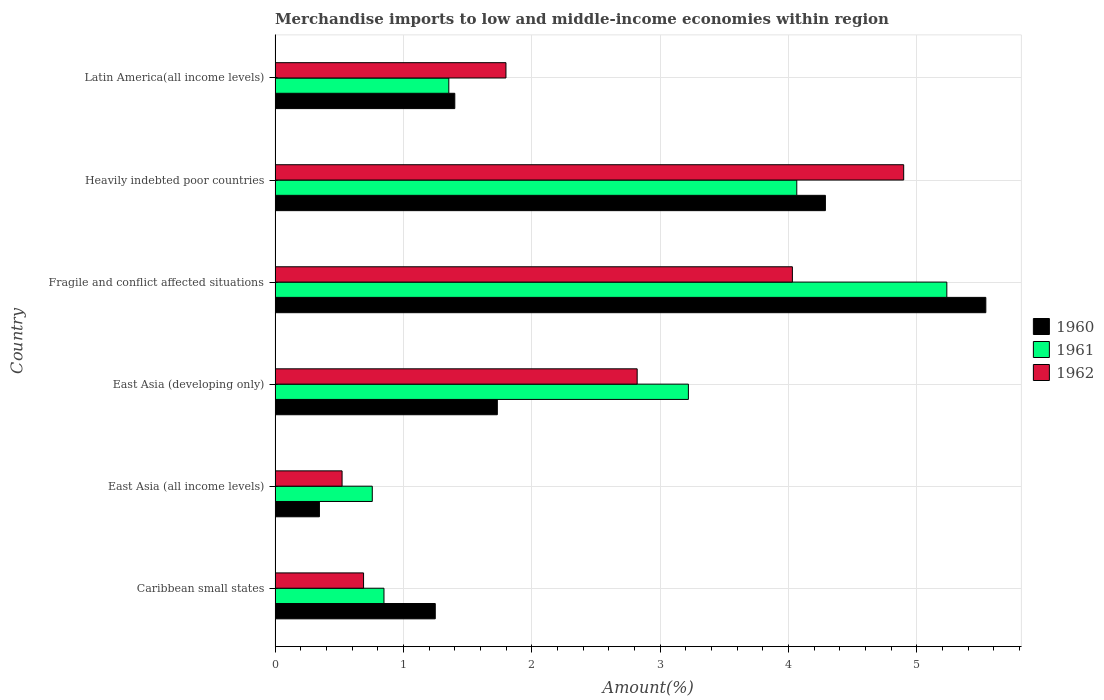Are the number of bars per tick equal to the number of legend labels?
Your response must be concise. Yes. How many bars are there on the 4th tick from the bottom?
Offer a very short reply. 3. What is the label of the 6th group of bars from the top?
Your answer should be compact. Caribbean small states. What is the percentage of amount earned from merchandise imports in 1962 in Latin America(all income levels)?
Give a very brief answer. 1.8. Across all countries, what is the maximum percentage of amount earned from merchandise imports in 1960?
Keep it short and to the point. 5.54. Across all countries, what is the minimum percentage of amount earned from merchandise imports in 1962?
Offer a very short reply. 0.52. In which country was the percentage of amount earned from merchandise imports in 1961 maximum?
Make the answer very short. Fragile and conflict affected situations. In which country was the percentage of amount earned from merchandise imports in 1961 minimum?
Make the answer very short. East Asia (all income levels). What is the total percentage of amount earned from merchandise imports in 1962 in the graph?
Your answer should be very brief. 14.76. What is the difference between the percentage of amount earned from merchandise imports in 1962 in Caribbean small states and that in East Asia (all income levels)?
Your answer should be very brief. 0.17. What is the difference between the percentage of amount earned from merchandise imports in 1961 in Caribbean small states and the percentage of amount earned from merchandise imports in 1962 in Fragile and conflict affected situations?
Your response must be concise. -3.18. What is the average percentage of amount earned from merchandise imports in 1960 per country?
Provide a succinct answer. 2.43. What is the difference between the percentage of amount earned from merchandise imports in 1961 and percentage of amount earned from merchandise imports in 1962 in Caribbean small states?
Make the answer very short. 0.16. In how many countries, is the percentage of amount earned from merchandise imports in 1961 greater than 2.4 %?
Provide a short and direct response. 3. What is the ratio of the percentage of amount earned from merchandise imports in 1961 in Heavily indebted poor countries to that in Latin America(all income levels)?
Your response must be concise. 3. Is the percentage of amount earned from merchandise imports in 1961 in East Asia (developing only) less than that in Fragile and conflict affected situations?
Provide a short and direct response. Yes. Is the difference between the percentage of amount earned from merchandise imports in 1961 in East Asia (all income levels) and Latin America(all income levels) greater than the difference between the percentage of amount earned from merchandise imports in 1962 in East Asia (all income levels) and Latin America(all income levels)?
Make the answer very short. Yes. What is the difference between the highest and the second highest percentage of amount earned from merchandise imports in 1961?
Keep it short and to the point. 1.17. What is the difference between the highest and the lowest percentage of amount earned from merchandise imports in 1961?
Give a very brief answer. 4.48. In how many countries, is the percentage of amount earned from merchandise imports in 1961 greater than the average percentage of amount earned from merchandise imports in 1961 taken over all countries?
Your answer should be very brief. 3. Is the sum of the percentage of amount earned from merchandise imports in 1960 in East Asia (all income levels) and Latin America(all income levels) greater than the maximum percentage of amount earned from merchandise imports in 1962 across all countries?
Ensure brevity in your answer.  No. What does the 3rd bar from the top in Fragile and conflict affected situations represents?
Ensure brevity in your answer.  1960. Is it the case that in every country, the sum of the percentage of amount earned from merchandise imports in 1962 and percentage of amount earned from merchandise imports in 1961 is greater than the percentage of amount earned from merchandise imports in 1960?
Give a very brief answer. Yes. How many bars are there?
Offer a terse response. 18. How many legend labels are there?
Provide a succinct answer. 3. What is the title of the graph?
Give a very brief answer. Merchandise imports to low and middle-income economies within region. What is the label or title of the X-axis?
Ensure brevity in your answer.  Amount(%). What is the label or title of the Y-axis?
Offer a terse response. Country. What is the Amount(%) in 1960 in Caribbean small states?
Your response must be concise. 1.25. What is the Amount(%) of 1961 in Caribbean small states?
Offer a very short reply. 0.85. What is the Amount(%) in 1962 in Caribbean small states?
Your response must be concise. 0.69. What is the Amount(%) of 1960 in East Asia (all income levels)?
Provide a short and direct response. 0.35. What is the Amount(%) of 1961 in East Asia (all income levels)?
Offer a very short reply. 0.76. What is the Amount(%) in 1962 in East Asia (all income levels)?
Keep it short and to the point. 0.52. What is the Amount(%) in 1960 in East Asia (developing only)?
Provide a short and direct response. 1.73. What is the Amount(%) in 1961 in East Asia (developing only)?
Give a very brief answer. 3.22. What is the Amount(%) in 1962 in East Asia (developing only)?
Offer a very short reply. 2.82. What is the Amount(%) in 1960 in Fragile and conflict affected situations?
Offer a very short reply. 5.54. What is the Amount(%) of 1961 in Fragile and conflict affected situations?
Your answer should be very brief. 5.23. What is the Amount(%) in 1962 in Fragile and conflict affected situations?
Provide a short and direct response. 4.03. What is the Amount(%) in 1960 in Heavily indebted poor countries?
Your answer should be very brief. 4.29. What is the Amount(%) in 1961 in Heavily indebted poor countries?
Your response must be concise. 4.06. What is the Amount(%) of 1962 in Heavily indebted poor countries?
Offer a terse response. 4.9. What is the Amount(%) of 1960 in Latin America(all income levels)?
Your response must be concise. 1.4. What is the Amount(%) of 1961 in Latin America(all income levels)?
Ensure brevity in your answer.  1.35. What is the Amount(%) of 1962 in Latin America(all income levels)?
Your answer should be very brief. 1.8. Across all countries, what is the maximum Amount(%) of 1960?
Provide a succinct answer. 5.54. Across all countries, what is the maximum Amount(%) of 1961?
Keep it short and to the point. 5.23. Across all countries, what is the maximum Amount(%) of 1962?
Make the answer very short. 4.9. Across all countries, what is the minimum Amount(%) in 1960?
Your response must be concise. 0.35. Across all countries, what is the minimum Amount(%) of 1961?
Offer a very short reply. 0.76. Across all countries, what is the minimum Amount(%) of 1962?
Ensure brevity in your answer.  0.52. What is the total Amount(%) of 1960 in the graph?
Provide a short and direct response. 14.55. What is the total Amount(%) in 1961 in the graph?
Offer a terse response. 15.48. What is the total Amount(%) of 1962 in the graph?
Provide a short and direct response. 14.76. What is the difference between the Amount(%) in 1960 in Caribbean small states and that in East Asia (all income levels)?
Keep it short and to the point. 0.9. What is the difference between the Amount(%) of 1961 in Caribbean small states and that in East Asia (all income levels)?
Give a very brief answer. 0.09. What is the difference between the Amount(%) of 1962 in Caribbean small states and that in East Asia (all income levels)?
Ensure brevity in your answer.  0.17. What is the difference between the Amount(%) in 1960 in Caribbean small states and that in East Asia (developing only)?
Provide a short and direct response. -0.48. What is the difference between the Amount(%) of 1961 in Caribbean small states and that in East Asia (developing only)?
Make the answer very short. -2.37. What is the difference between the Amount(%) of 1962 in Caribbean small states and that in East Asia (developing only)?
Provide a succinct answer. -2.13. What is the difference between the Amount(%) of 1960 in Caribbean small states and that in Fragile and conflict affected situations?
Your answer should be very brief. -4.29. What is the difference between the Amount(%) of 1961 in Caribbean small states and that in Fragile and conflict affected situations?
Your answer should be compact. -4.39. What is the difference between the Amount(%) of 1962 in Caribbean small states and that in Fragile and conflict affected situations?
Offer a terse response. -3.34. What is the difference between the Amount(%) of 1960 in Caribbean small states and that in Heavily indebted poor countries?
Your answer should be very brief. -3.04. What is the difference between the Amount(%) of 1961 in Caribbean small states and that in Heavily indebted poor countries?
Offer a very short reply. -3.22. What is the difference between the Amount(%) in 1962 in Caribbean small states and that in Heavily indebted poor countries?
Provide a short and direct response. -4.21. What is the difference between the Amount(%) of 1960 in Caribbean small states and that in Latin America(all income levels)?
Make the answer very short. -0.15. What is the difference between the Amount(%) in 1961 in Caribbean small states and that in Latin America(all income levels)?
Provide a short and direct response. -0.51. What is the difference between the Amount(%) of 1962 in Caribbean small states and that in Latin America(all income levels)?
Keep it short and to the point. -1.11. What is the difference between the Amount(%) in 1960 in East Asia (all income levels) and that in East Asia (developing only)?
Offer a very short reply. -1.39. What is the difference between the Amount(%) of 1961 in East Asia (all income levels) and that in East Asia (developing only)?
Make the answer very short. -2.46. What is the difference between the Amount(%) in 1962 in East Asia (all income levels) and that in East Asia (developing only)?
Offer a very short reply. -2.3. What is the difference between the Amount(%) of 1960 in East Asia (all income levels) and that in Fragile and conflict affected situations?
Offer a terse response. -5.19. What is the difference between the Amount(%) of 1961 in East Asia (all income levels) and that in Fragile and conflict affected situations?
Offer a terse response. -4.48. What is the difference between the Amount(%) in 1962 in East Asia (all income levels) and that in Fragile and conflict affected situations?
Your response must be concise. -3.51. What is the difference between the Amount(%) in 1960 in East Asia (all income levels) and that in Heavily indebted poor countries?
Ensure brevity in your answer.  -3.94. What is the difference between the Amount(%) of 1961 in East Asia (all income levels) and that in Heavily indebted poor countries?
Make the answer very short. -3.31. What is the difference between the Amount(%) of 1962 in East Asia (all income levels) and that in Heavily indebted poor countries?
Your response must be concise. -4.38. What is the difference between the Amount(%) of 1960 in East Asia (all income levels) and that in Latin America(all income levels)?
Ensure brevity in your answer.  -1.05. What is the difference between the Amount(%) of 1961 in East Asia (all income levels) and that in Latin America(all income levels)?
Ensure brevity in your answer.  -0.6. What is the difference between the Amount(%) of 1962 in East Asia (all income levels) and that in Latin America(all income levels)?
Provide a succinct answer. -1.28. What is the difference between the Amount(%) of 1960 in East Asia (developing only) and that in Fragile and conflict affected situations?
Your answer should be very brief. -3.81. What is the difference between the Amount(%) in 1961 in East Asia (developing only) and that in Fragile and conflict affected situations?
Give a very brief answer. -2.01. What is the difference between the Amount(%) of 1962 in East Asia (developing only) and that in Fragile and conflict affected situations?
Keep it short and to the point. -1.21. What is the difference between the Amount(%) in 1960 in East Asia (developing only) and that in Heavily indebted poor countries?
Give a very brief answer. -2.56. What is the difference between the Amount(%) in 1961 in East Asia (developing only) and that in Heavily indebted poor countries?
Provide a short and direct response. -0.84. What is the difference between the Amount(%) in 1962 in East Asia (developing only) and that in Heavily indebted poor countries?
Your answer should be compact. -2.08. What is the difference between the Amount(%) of 1960 in East Asia (developing only) and that in Latin America(all income levels)?
Your answer should be very brief. 0.33. What is the difference between the Amount(%) in 1961 in East Asia (developing only) and that in Latin America(all income levels)?
Keep it short and to the point. 1.87. What is the difference between the Amount(%) in 1962 in East Asia (developing only) and that in Latin America(all income levels)?
Make the answer very short. 1.02. What is the difference between the Amount(%) of 1960 in Fragile and conflict affected situations and that in Heavily indebted poor countries?
Your answer should be compact. 1.25. What is the difference between the Amount(%) of 1961 in Fragile and conflict affected situations and that in Heavily indebted poor countries?
Your response must be concise. 1.17. What is the difference between the Amount(%) of 1962 in Fragile and conflict affected situations and that in Heavily indebted poor countries?
Keep it short and to the point. -0.87. What is the difference between the Amount(%) in 1960 in Fragile and conflict affected situations and that in Latin America(all income levels)?
Offer a terse response. 4.14. What is the difference between the Amount(%) in 1961 in Fragile and conflict affected situations and that in Latin America(all income levels)?
Keep it short and to the point. 3.88. What is the difference between the Amount(%) of 1962 in Fragile and conflict affected situations and that in Latin America(all income levels)?
Offer a terse response. 2.23. What is the difference between the Amount(%) in 1960 in Heavily indebted poor countries and that in Latin America(all income levels)?
Give a very brief answer. 2.89. What is the difference between the Amount(%) of 1961 in Heavily indebted poor countries and that in Latin America(all income levels)?
Offer a very short reply. 2.71. What is the difference between the Amount(%) of 1962 in Heavily indebted poor countries and that in Latin America(all income levels)?
Give a very brief answer. 3.1. What is the difference between the Amount(%) in 1960 in Caribbean small states and the Amount(%) in 1961 in East Asia (all income levels)?
Keep it short and to the point. 0.49. What is the difference between the Amount(%) in 1960 in Caribbean small states and the Amount(%) in 1962 in East Asia (all income levels)?
Provide a succinct answer. 0.73. What is the difference between the Amount(%) of 1961 in Caribbean small states and the Amount(%) of 1962 in East Asia (all income levels)?
Provide a succinct answer. 0.33. What is the difference between the Amount(%) in 1960 in Caribbean small states and the Amount(%) in 1961 in East Asia (developing only)?
Offer a very short reply. -1.97. What is the difference between the Amount(%) of 1960 in Caribbean small states and the Amount(%) of 1962 in East Asia (developing only)?
Your answer should be compact. -1.57. What is the difference between the Amount(%) of 1961 in Caribbean small states and the Amount(%) of 1962 in East Asia (developing only)?
Offer a terse response. -1.97. What is the difference between the Amount(%) in 1960 in Caribbean small states and the Amount(%) in 1961 in Fragile and conflict affected situations?
Ensure brevity in your answer.  -3.99. What is the difference between the Amount(%) of 1960 in Caribbean small states and the Amount(%) of 1962 in Fragile and conflict affected situations?
Keep it short and to the point. -2.78. What is the difference between the Amount(%) of 1961 in Caribbean small states and the Amount(%) of 1962 in Fragile and conflict affected situations?
Provide a short and direct response. -3.18. What is the difference between the Amount(%) of 1960 in Caribbean small states and the Amount(%) of 1961 in Heavily indebted poor countries?
Provide a succinct answer. -2.82. What is the difference between the Amount(%) in 1960 in Caribbean small states and the Amount(%) in 1962 in Heavily indebted poor countries?
Your answer should be very brief. -3.65. What is the difference between the Amount(%) in 1961 in Caribbean small states and the Amount(%) in 1962 in Heavily indebted poor countries?
Offer a very short reply. -4.05. What is the difference between the Amount(%) in 1960 in Caribbean small states and the Amount(%) in 1961 in Latin America(all income levels)?
Keep it short and to the point. -0.11. What is the difference between the Amount(%) in 1960 in Caribbean small states and the Amount(%) in 1962 in Latin America(all income levels)?
Offer a very short reply. -0.55. What is the difference between the Amount(%) of 1961 in Caribbean small states and the Amount(%) of 1962 in Latin America(all income levels)?
Make the answer very short. -0.95. What is the difference between the Amount(%) of 1960 in East Asia (all income levels) and the Amount(%) of 1961 in East Asia (developing only)?
Give a very brief answer. -2.87. What is the difference between the Amount(%) of 1960 in East Asia (all income levels) and the Amount(%) of 1962 in East Asia (developing only)?
Offer a very short reply. -2.48. What is the difference between the Amount(%) in 1961 in East Asia (all income levels) and the Amount(%) in 1962 in East Asia (developing only)?
Ensure brevity in your answer.  -2.06. What is the difference between the Amount(%) in 1960 in East Asia (all income levels) and the Amount(%) in 1961 in Fragile and conflict affected situations?
Ensure brevity in your answer.  -4.89. What is the difference between the Amount(%) of 1960 in East Asia (all income levels) and the Amount(%) of 1962 in Fragile and conflict affected situations?
Offer a terse response. -3.69. What is the difference between the Amount(%) in 1961 in East Asia (all income levels) and the Amount(%) in 1962 in Fragile and conflict affected situations?
Ensure brevity in your answer.  -3.27. What is the difference between the Amount(%) of 1960 in East Asia (all income levels) and the Amount(%) of 1961 in Heavily indebted poor countries?
Ensure brevity in your answer.  -3.72. What is the difference between the Amount(%) of 1960 in East Asia (all income levels) and the Amount(%) of 1962 in Heavily indebted poor countries?
Make the answer very short. -4.55. What is the difference between the Amount(%) of 1961 in East Asia (all income levels) and the Amount(%) of 1962 in Heavily indebted poor countries?
Keep it short and to the point. -4.14. What is the difference between the Amount(%) in 1960 in East Asia (all income levels) and the Amount(%) in 1961 in Latin America(all income levels)?
Provide a short and direct response. -1.01. What is the difference between the Amount(%) in 1960 in East Asia (all income levels) and the Amount(%) in 1962 in Latin America(all income levels)?
Offer a very short reply. -1.45. What is the difference between the Amount(%) of 1961 in East Asia (all income levels) and the Amount(%) of 1962 in Latin America(all income levels)?
Your answer should be very brief. -1.04. What is the difference between the Amount(%) in 1960 in East Asia (developing only) and the Amount(%) in 1961 in Fragile and conflict affected situations?
Make the answer very short. -3.5. What is the difference between the Amount(%) in 1960 in East Asia (developing only) and the Amount(%) in 1962 in Fragile and conflict affected situations?
Make the answer very short. -2.3. What is the difference between the Amount(%) of 1961 in East Asia (developing only) and the Amount(%) of 1962 in Fragile and conflict affected situations?
Make the answer very short. -0.81. What is the difference between the Amount(%) of 1960 in East Asia (developing only) and the Amount(%) of 1961 in Heavily indebted poor countries?
Provide a succinct answer. -2.33. What is the difference between the Amount(%) in 1960 in East Asia (developing only) and the Amount(%) in 1962 in Heavily indebted poor countries?
Offer a terse response. -3.17. What is the difference between the Amount(%) in 1961 in East Asia (developing only) and the Amount(%) in 1962 in Heavily indebted poor countries?
Keep it short and to the point. -1.68. What is the difference between the Amount(%) of 1960 in East Asia (developing only) and the Amount(%) of 1961 in Latin America(all income levels)?
Offer a terse response. 0.38. What is the difference between the Amount(%) in 1960 in East Asia (developing only) and the Amount(%) in 1962 in Latin America(all income levels)?
Your answer should be compact. -0.07. What is the difference between the Amount(%) in 1961 in East Asia (developing only) and the Amount(%) in 1962 in Latin America(all income levels)?
Provide a succinct answer. 1.42. What is the difference between the Amount(%) of 1960 in Fragile and conflict affected situations and the Amount(%) of 1961 in Heavily indebted poor countries?
Give a very brief answer. 1.47. What is the difference between the Amount(%) of 1960 in Fragile and conflict affected situations and the Amount(%) of 1962 in Heavily indebted poor countries?
Your answer should be compact. 0.64. What is the difference between the Amount(%) of 1961 in Fragile and conflict affected situations and the Amount(%) of 1962 in Heavily indebted poor countries?
Ensure brevity in your answer.  0.34. What is the difference between the Amount(%) in 1960 in Fragile and conflict affected situations and the Amount(%) in 1961 in Latin America(all income levels)?
Your answer should be very brief. 4.18. What is the difference between the Amount(%) in 1960 in Fragile and conflict affected situations and the Amount(%) in 1962 in Latin America(all income levels)?
Your answer should be very brief. 3.74. What is the difference between the Amount(%) in 1961 in Fragile and conflict affected situations and the Amount(%) in 1962 in Latin America(all income levels)?
Provide a succinct answer. 3.44. What is the difference between the Amount(%) of 1960 in Heavily indebted poor countries and the Amount(%) of 1961 in Latin America(all income levels)?
Your answer should be compact. 2.93. What is the difference between the Amount(%) of 1960 in Heavily indebted poor countries and the Amount(%) of 1962 in Latin America(all income levels)?
Offer a very short reply. 2.49. What is the difference between the Amount(%) of 1961 in Heavily indebted poor countries and the Amount(%) of 1962 in Latin America(all income levels)?
Offer a terse response. 2.27. What is the average Amount(%) in 1960 per country?
Make the answer very short. 2.43. What is the average Amount(%) in 1961 per country?
Give a very brief answer. 2.58. What is the average Amount(%) of 1962 per country?
Offer a terse response. 2.46. What is the difference between the Amount(%) of 1960 and Amount(%) of 1961 in Caribbean small states?
Provide a succinct answer. 0.4. What is the difference between the Amount(%) of 1960 and Amount(%) of 1962 in Caribbean small states?
Offer a very short reply. 0.56. What is the difference between the Amount(%) of 1961 and Amount(%) of 1962 in Caribbean small states?
Your answer should be compact. 0.16. What is the difference between the Amount(%) in 1960 and Amount(%) in 1961 in East Asia (all income levels)?
Offer a very short reply. -0.41. What is the difference between the Amount(%) of 1960 and Amount(%) of 1962 in East Asia (all income levels)?
Offer a very short reply. -0.18. What is the difference between the Amount(%) in 1961 and Amount(%) in 1962 in East Asia (all income levels)?
Ensure brevity in your answer.  0.24. What is the difference between the Amount(%) of 1960 and Amount(%) of 1961 in East Asia (developing only)?
Your response must be concise. -1.49. What is the difference between the Amount(%) of 1960 and Amount(%) of 1962 in East Asia (developing only)?
Your answer should be very brief. -1.09. What is the difference between the Amount(%) in 1961 and Amount(%) in 1962 in East Asia (developing only)?
Offer a very short reply. 0.4. What is the difference between the Amount(%) in 1960 and Amount(%) in 1961 in Fragile and conflict affected situations?
Ensure brevity in your answer.  0.3. What is the difference between the Amount(%) in 1960 and Amount(%) in 1962 in Fragile and conflict affected situations?
Ensure brevity in your answer.  1.51. What is the difference between the Amount(%) of 1961 and Amount(%) of 1962 in Fragile and conflict affected situations?
Provide a short and direct response. 1.2. What is the difference between the Amount(%) in 1960 and Amount(%) in 1961 in Heavily indebted poor countries?
Offer a very short reply. 0.22. What is the difference between the Amount(%) in 1960 and Amount(%) in 1962 in Heavily indebted poor countries?
Your answer should be compact. -0.61. What is the difference between the Amount(%) in 1961 and Amount(%) in 1962 in Heavily indebted poor countries?
Provide a short and direct response. -0.83. What is the difference between the Amount(%) of 1960 and Amount(%) of 1961 in Latin America(all income levels)?
Ensure brevity in your answer.  0.05. What is the difference between the Amount(%) in 1960 and Amount(%) in 1962 in Latin America(all income levels)?
Provide a short and direct response. -0.4. What is the difference between the Amount(%) in 1961 and Amount(%) in 1962 in Latin America(all income levels)?
Give a very brief answer. -0.45. What is the ratio of the Amount(%) in 1960 in Caribbean small states to that in East Asia (all income levels)?
Offer a terse response. 3.61. What is the ratio of the Amount(%) in 1961 in Caribbean small states to that in East Asia (all income levels)?
Provide a succinct answer. 1.12. What is the ratio of the Amount(%) in 1962 in Caribbean small states to that in East Asia (all income levels)?
Give a very brief answer. 1.32. What is the ratio of the Amount(%) in 1960 in Caribbean small states to that in East Asia (developing only)?
Offer a terse response. 0.72. What is the ratio of the Amount(%) of 1961 in Caribbean small states to that in East Asia (developing only)?
Your answer should be compact. 0.26. What is the ratio of the Amount(%) in 1962 in Caribbean small states to that in East Asia (developing only)?
Offer a terse response. 0.24. What is the ratio of the Amount(%) in 1960 in Caribbean small states to that in Fragile and conflict affected situations?
Offer a terse response. 0.23. What is the ratio of the Amount(%) of 1961 in Caribbean small states to that in Fragile and conflict affected situations?
Offer a very short reply. 0.16. What is the ratio of the Amount(%) of 1962 in Caribbean small states to that in Fragile and conflict affected situations?
Give a very brief answer. 0.17. What is the ratio of the Amount(%) of 1960 in Caribbean small states to that in Heavily indebted poor countries?
Provide a succinct answer. 0.29. What is the ratio of the Amount(%) in 1961 in Caribbean small states to that in Heavily indebted poor countries?
Provide a succinct answer. 0.21. What is the ratio of the Amount(%) in 1962 in Caribbean small states to that in Heavily indebted poor countries?
Offer a terse response. 0.14. What is the ratio of the Amount(%) of 1960 in Caribbean small states to that in Latin America(all income levels)?
Keep it short and to the point. 0.89. What is the ratio of the Amount(%) of 1961 in Caribbean small states to that in Latin America(all income levels)?
Provide a succinct answer. 0.63. What is the ratio of the Amount(%) of 1962 in Caribbean small states to that in Latin America(all income levels)?
Offer a very short reply. 0.38. What is the ratio of the Amount(%) of 1960 in East Asia (all income levels) to that in East Asia (developing only)?
Provide a succinct answer. 0.2. What is the ratio of the Amount(%) in 1961 in East Asia (all income levels) to that in East Asia (developing only)?
Your answer should be very brief. 0.24. What is the ratio of the Amount(%) in 1962 in East Asia (all income levels) to that in East Asia (developing only)?
Your answer should be very brief. 0.18. What is the ratio of the Amount(%) in 1960 in East Asia (all income levels) to that in Fragile and conflict affected situations?
Your answer should be compact. 0.06. What is the ratio of the Amount(%) of 1961 in East Asia (all income levels) to that in Fragile and conflict affected situations?
Provide a succinct answer. 0.14. What is the ratio of the Amount(%) of 1962 in East Asia (all income levels) to that in Fragile and conflict affected situations?
Provide a succinct answer. 0.13. What is the ratio of the Amount(%) in 1960 in East Asia (all income levels) to that in Heavily indebted poor countries?
Ensure brevity in your answer.  0.08. What is the ratio of the Amount(%) in 1961 in East Asia (all income levels) to that in Heavily indebted poor countries?
Your answer should be compact. 0.19. What is the ratio of the Amount(%) of 1962 in East Asia (all income levels) to that in Heavily indebted poor countries?
Give a very brief answer. 0.11. What is the ratio of the Amount(%) of 1960 in East Asia (all income levels) to that in Latin America(all income levels)?
Your response must be concise. 0.25. What is the ratio of the Amount(%) in 1961 in East Asia (all income levels) to that in Latin America(all income levels)?
Your answer should be very brief. 0.56. What is the ratio of the Amount(%) in 1962 in East Asia (all income levels) to that in Latin America(all income levels)?
Ensure brevity in your answer.  0.29. What is the ratio of the Amount(%) of 1960 in East Asia (developing only) to that in Fragile and conflict affected situations?
Provide a short and direct response. 0.31. What is the ratio of the Amount(%) of 1961 in East Asia (developing only) to that in Fragile and conflict affected situations?
Make the answer very short. 0.62. What is the ratio of the Amount(%) in 1962 in East Asia (developing only) to that in Fragile and conflict affected situations?
Provide a short and direct response. 0.7. What is the ratio of the Amount(%) of 1960 in East Asia (developing only) to that in Heavily indebted poor countries?
Your answer should be compact. 0.4. What is the ratio of the Amount(%) of 1961 in East Asia (developing only) to that in Heavily indebted poor countries?
Keep it short and to the point. 0.79. What is the ratio of the Amount(%) of 1962 in East Asia (developing only) to that in Heavily indebted poor countries?
Your response must be concise. 0.58. What is the ratio of the Amount(%) of 1960 in East Asia (developing only) to that in Latin America(all income levels)?
Ensure brevity in your answer.  1.24. What is the ratio of the Amount(%) in 1961 in East Asia (developing only) to that in Latin America(all income levels)?
Your response must be concise. 2.38. What is the ratio of the Amount(%) in 1962 in East Asia (developing only) to that in Latin America(all income levels)?
Offer a terse response. 1.57. What is the ratio of the Amount(%) in 1960 in Fragile and conflict affected situations to that in Heavily indebted poor countries?
Make the answer very short. 1.29. What is the ratio of the Amount(%) of 1961 in Fragile and conflict affected situations to that in Heavily indebted poor countries?
Give a very brief answer. 1.29. What is the ratio of the Amount(%) of 1962 in Fragile and conflict affected situations to that in Heavily indebted poor countries?
Your answer should be compact. 0.82. What is the ratio of the Amount(%) of 1960 in Fragile and conflict affected situations to that in Latin America(all income levels)?
Offer a terse response. 3.95. What is the ratio of the Amount(%) in 1961 in Fragile and conflict affected situations to that in Latin America(all income levels)?
Keep it short and to the point. 3.87. What is the ratio of the Amount(%) in 1962 in Fragile and conflict affected situations to that in Latin America(all income levels)?
Offer a terse response. 2.24. What is the ratio of the Amount(%) in 1960 in Heavily indebted poor countries to that in Latin America(all income levels)?
Make the answer very short. 3.06. What is the ratio of the Amount(%) of 1961 in Heavily indebted poor countries to that in Latin America(all income levels)?
Offer a very short reply. 3. What is the ratio of the Amount(%) in 1962 in Heavily indebted poor countries to that in Latin America(all income levels)?
Ensure brevity in your answer.  2.72. What is the difference between the highest and the second highest Amount(%) of 1961?
Ensure brevity in your answer.  1.17. What is the difference between the highest and the second highest Amount(%) in 1962?
Ensure brevity in your answer.  0.87. What is the difference between the highest and the lowest Amount(%) in 1960?
Your answer should be compact. 5.19. What is the difference between the highest and the lowest Amount(%) of 1961?
Keep it short and to the point. 4.48. What is the difference between the highest and the lowest Amount(%) of 1962?
Offer a terse response. 4.38. 